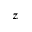<formula> <loc_0><loc_0><loc_500><loc_500>z</formula> 